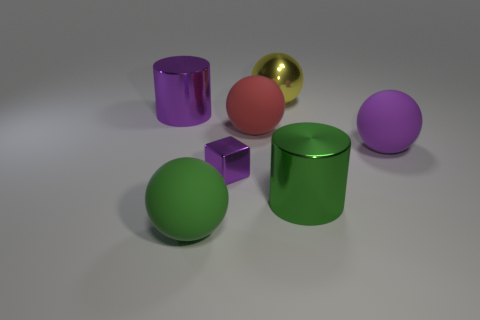Are there any other things that have the same shape as the large purple metallic thing?
Offer a terse response. Yes. What is the color of the shiny thing that is the same shape as the red rubber thing?
Ensure brevity in your answer.  Yellow. Is the small purple shiny thing the same shape as the green rubber object?
Provide a short and direct response. No. How many spheres are purple shiny things or small gray rubber objects?
Your response must be concise. 0. What is the color of the sphere that is made of the same material as the small purple cube?
Your answer should be compact. Yellow. There is a purple shiny object in front of the purple ball; is its size the same as the large purple sphere?
Make the answer very short. No. Does the large purple cylinder have the same material as the big sphere that is behind the big red matte ball?
Keep it short and to the point. Yes. There is a large shiny thing in front of the red matte sphere; what is its color?
Keep it short and to the point. Green. There is a big cylinder that is behind the small shiny cube; is there a large red matte object that is on the left side of it?
Ensure brevity in your answer.  No. There is a large rubber thing in front of the big purple matte sphere; is its color the same as the large cylinder in front of the purple shiny cylinder?
Your answer should be very brief. Yes. 